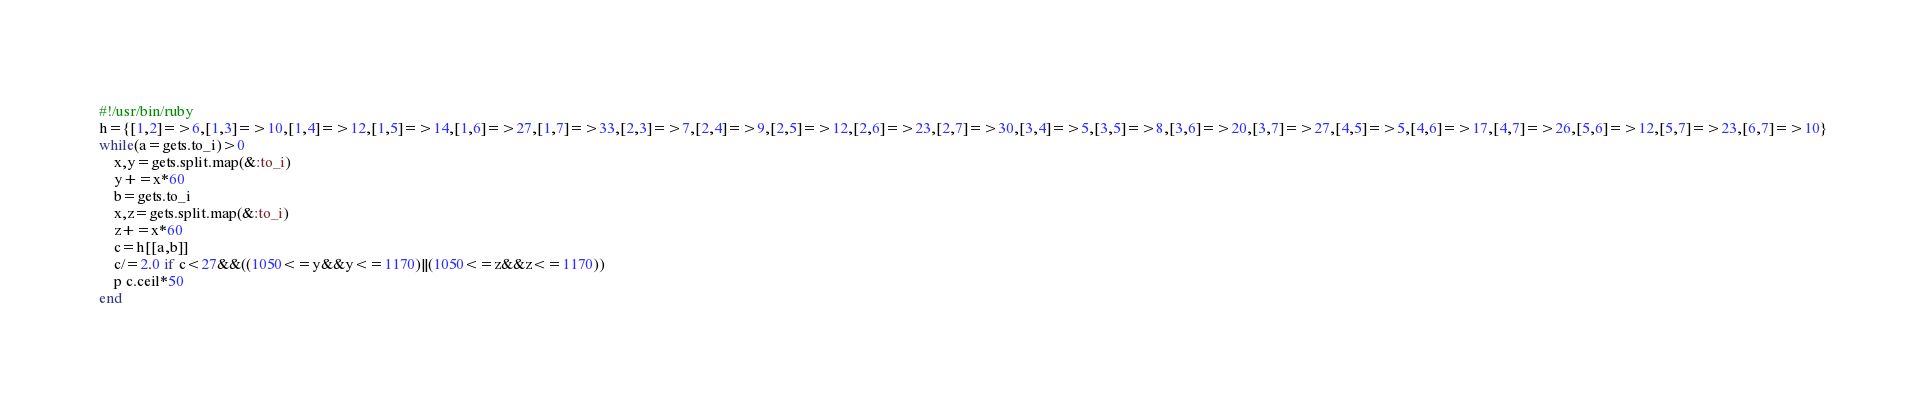Convert code to text. <code><loc_0><loc_0><loc_500><loc_500><_Ruby_>#!/usr/bin/ruby
h={[1,2]=>6,[1,3]=>10,[1,4]=>12,[1,5]=>14,[1,6]=>27,[1,7]=>33,[2,3]=>7,[2,4]=>9,[2,5]=>12,[2,6]=>23,[2,7]=>30,[3,4]=>5,[3,5]=>8,[3,6]=>20,[3,7]=>27,[4,5]=>5,[4,6]=>17,[4,7]=>26,[5,6]=>12,[5,7]=>23,[6,7]=>10}
while(a=gets.to_i)>0
	x,y=gets.split.map(&:to_i)
	y+=x*60
	b=gets.to_i
	x,z=gets.split.map(&:to_i)
	z+=x*60
	c=h[[a,b]]
	c/=2.0 if c<27&&((1050<=y&&y<=1170)||(1050<=z&&z<=1170))
	p c.ceil*50
end</code> 